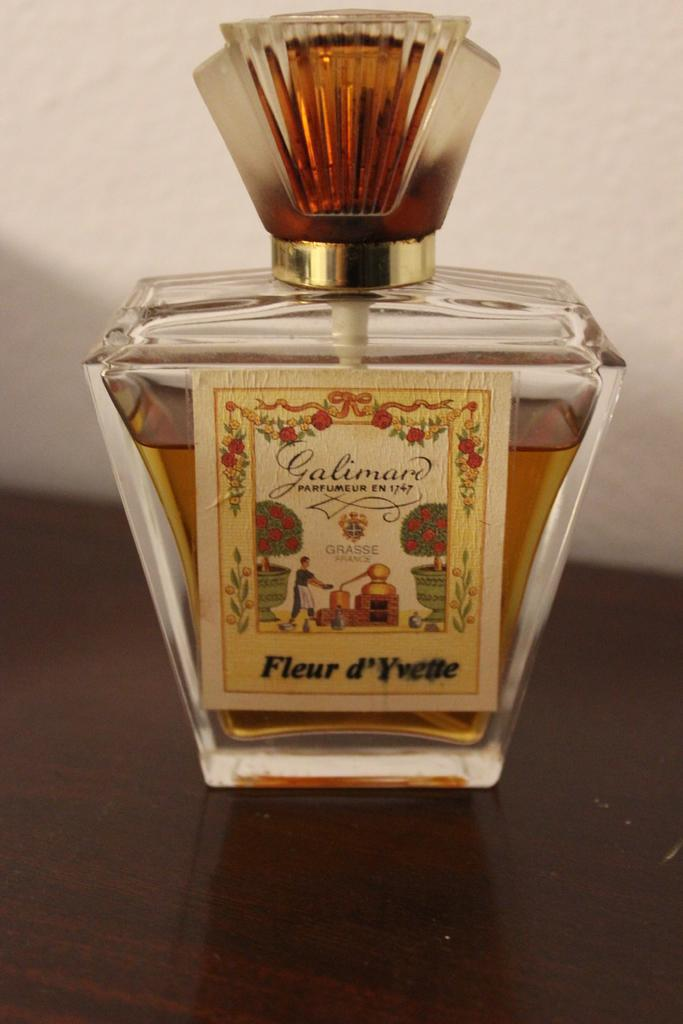Provide a one-sentence caption for the provided image. A bottle of Galimard parfumeur en 1747 sitting on a table. 